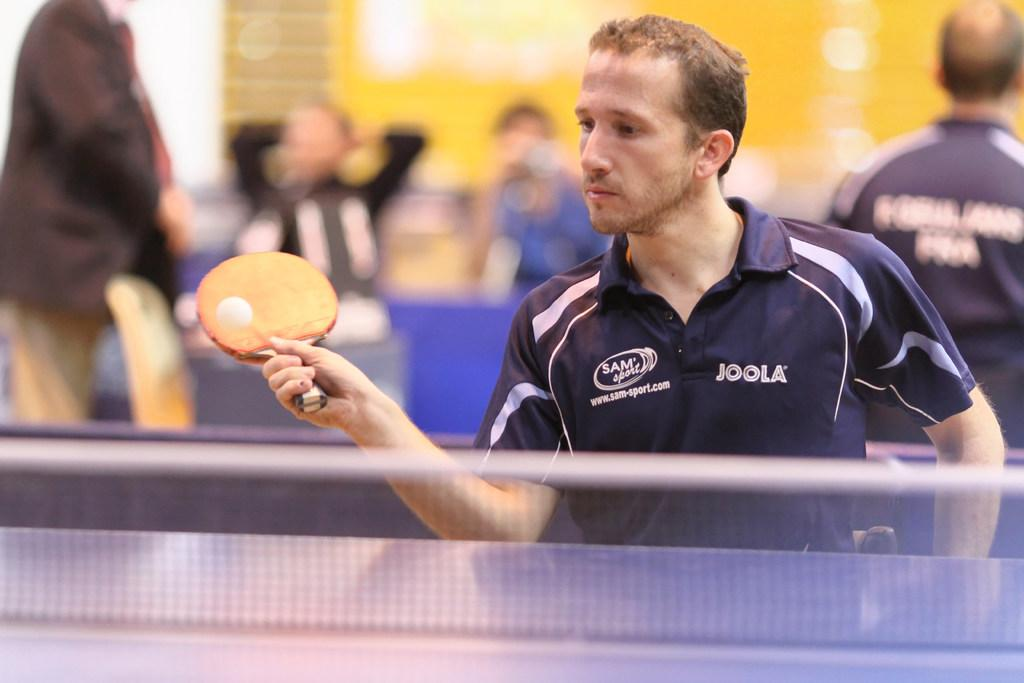<image>
Render a clear and concise summary of the photo. A man in a Sam Sport Joola shirt is playing table tennis. 